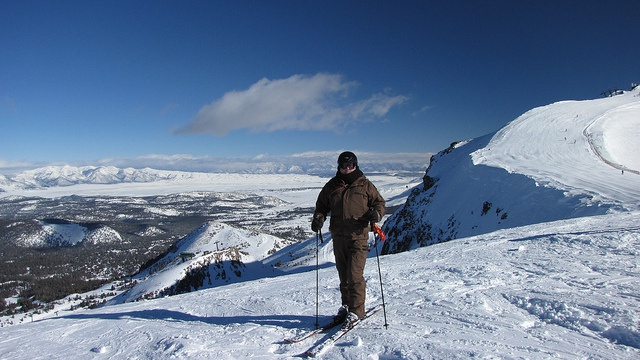Describe the objects in this image and their specific colors. I can see people in darkblue, black, gray, and maroon tones and skis in darkblue, black, lightgray, gray, and darkgray tones in this image. 